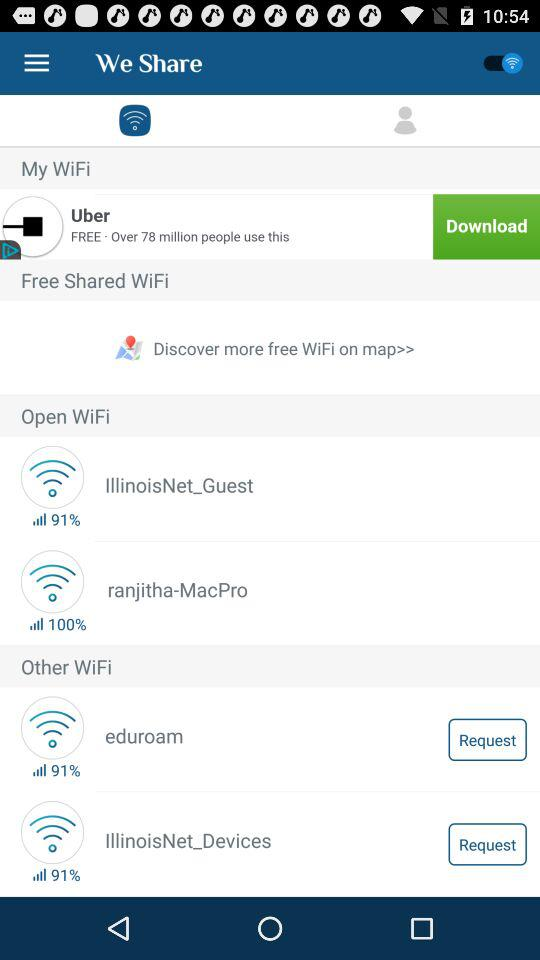How many wifi networks are available?
Answer the question using a single word or phrase. 4 